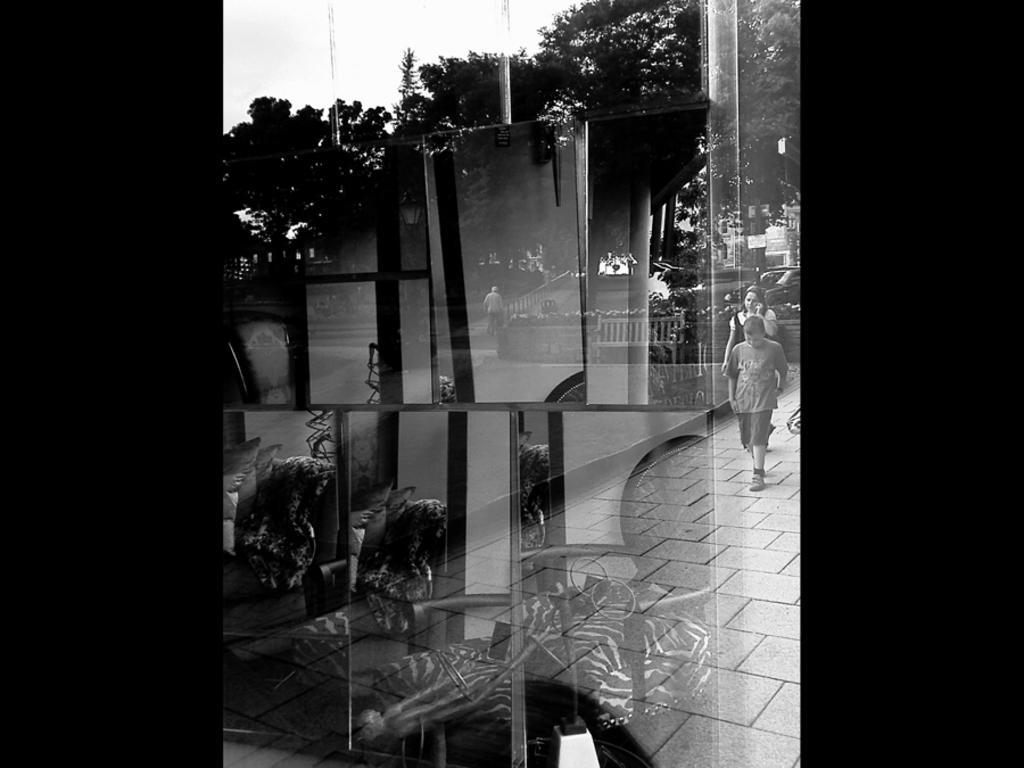Could you give a brief overview of what you see in this image? This is a black and white picture. In this picture, we see the chairs and the glass windows from which we can see a boy and a woman are walking on the pavement. She is talking on the mobile phone. Beside her, we see a bench. In the middle, we see a man is riding the bicycle. There are trees, poles and the cars in the background. At the top, we see the sky. On the right side and on the left side, it is black in color. 